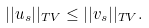Convert formula to latex. <formula><loc_0><loc_0><loc_500><loc_500>| | u _ { s } | | _ { T V } \leq | | v _ { s } | | _ { T V } .</formula> 